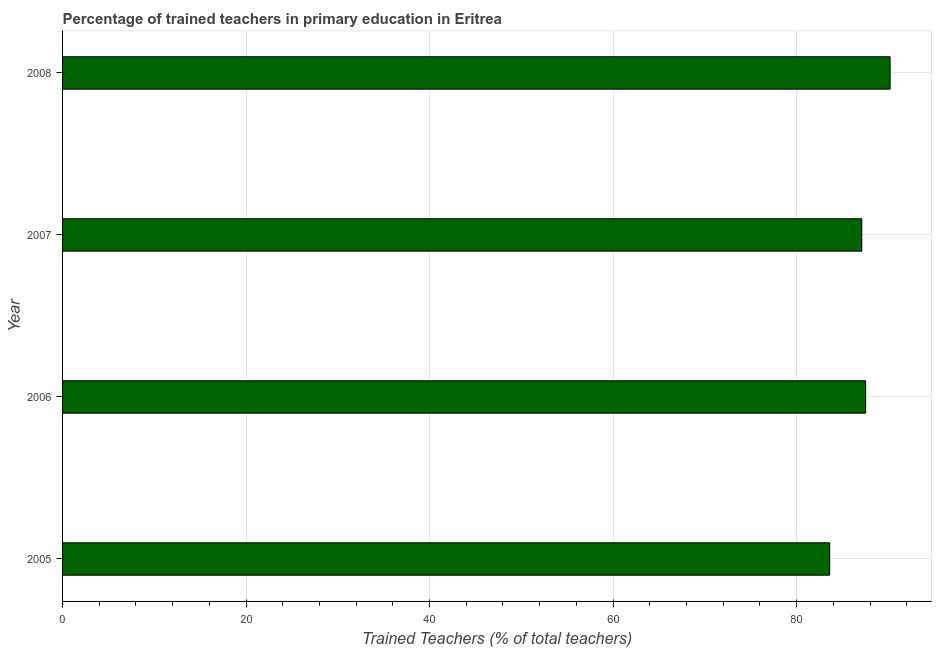What is the title of the graph?
Offer a terse response. Percentage of trained teachers in primary education in Eritrea. What is the label or title of the X-axis?
Give a very brief answer. Trained Teachers (% of total teachers). What is the label or title of the Y-axis?
Make the answer very short. Year. What is the percentage of trained teachers in 2008?
Make the answer very short. 90.19. Across all years, what is the maximum percentage of trained teachers?
Offer a terse response. 90.19. Across all years, what is the minimum percentage of trained teachers?
Provide a succinct answer. 83.61. What is the sum of the percentage of trained teachers?
Keep it short and to the point. 348.43. What is the difference between the percentage of trained teachers in 2007 and 2008?
Your response must be concise. -3.09. What is the average percentage of trained teachers per year?
Give a very brief answer. 87.11. What is the median percentage of trained teachers?
Your response must be concise. 87.31. What is the ratio of the percentage of trained teachers in 2005 to that in 2006?
Offer a terse response. 0.95. Is the percentage of trained teachers in 2005 less than that in 2008?
Provide a succinct answer. Yes. What is the difference between the highest and the second highest percentage of trained teachers?
Provide a succinct answer. 2.67. What is the difference between the highest and the lowest percentage of trained teachers?
Offer a very short reply. 6.59. How many bars are there?
Provide a succinct answer. 4. Are all the bars in the graph horizontal?
Give a very brief answer. Yes. How many years are there in the graph?
Your answer should be very brief. 4. Are the values on the major ticks of X-axis written in scientific E-notation?
Give a very brief answer. No. What is the Trained Teachers (% of total teachers) of 2005?
Keep it short and to the point. 83.61. What is the Trained Teachers (% of total teachers) of 2006?
Your answer should be very brief. 87.52. What is the Trained Teachers (% of total teachers) of 2007?
Give a very brief answer. 87.11. What is the Trained Teachers (% of total teachers) in 2008?
Ensure brevity in your answer.  90.19. What is the difference between the Trained Teachers (% of total teachers) in 2005 and 2006?
Make the answer very short. -3.92. What is the difference between the Trained Teachers (% of total teachers) in 2005 and 2007?
Your answer should be very brief. -3.5. What is the difference between the Trained Teachers (% of total teachers) in 2005 and 2008?
Offer a very short reply. -6.59. What is the difference between the Trained Teachers (% of total teachers) in 2006 and 2007?
Offer a terse response. 0.42. What is the difference between the Trained Teachers (% of total teachers) in 2006 and 2008?
Give a very brief answer. -2.67. What is the difference between the Trained Teachers (% of total teachers) in 2007 and 2008?
Offer a terse response. -3.09. What is the ratio of the Trained Teachers (% of total teachers) in 2005 to that in 2006?
Provide a short and direct response. 0.95. What is the ratio of the Trained Teachers (% of total teachers) in 2005 to that in 2008?
Provide a short and direct response. 0.93. What is the ratio of the Trained Teachers (% of total teachers) in 2006 to that in 2008?
Offer a very short reply. 0.97. 